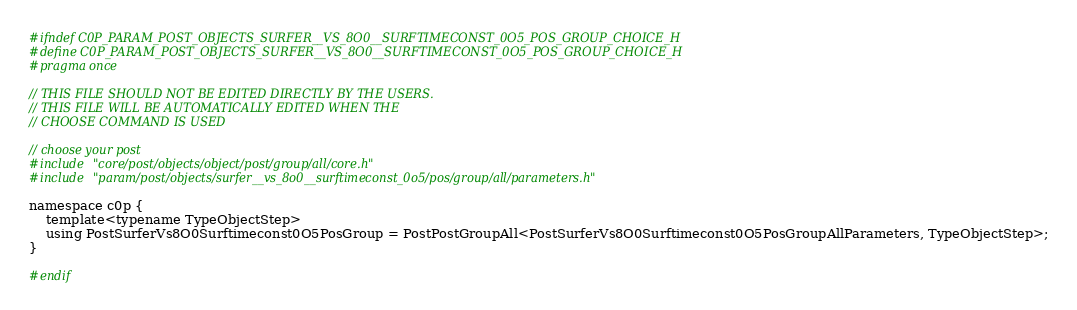<code> <loc_0><loc_0><loc_500><loc_500><_C_>#ifndef C0P_PARAM_POST_OBJECTS_SURFER__VS_8O0__SURFTIMECONST_0O5_POS_GROUP_CHOICE_H
#define C0P_PARAM_POST_OBJECTS_SURFER__VS_8O0__SURFTIMECONST_0O5_POS_GROUP_CHOICE_H
#pragma once

// THIS FILE SHOULD NOT BE EDITED DIRECTLY BY THE USERS.
// THIS FILE WILL BE AUTOMATICALLY EDITED WHEN THE
// CHOOSE COMMAND IS USED

// choose your post
#include "core/post/objects/object/post/group/all/core.h"
#include "param/post/objects/surfer__vs_8o0__surftimeconst_0o5/pos/group/all/parameters.h"

namespace c0p {
    template<typename TypeObjectStep>
    using PostSurferVs8O0Surftimeconst0O5PosGroup = PostPostGroupAll<PostSurferVs8O0Surftimeconst0O5PosGroupAllParameters, TypeObjectStep>;
}

#endif
</code> 